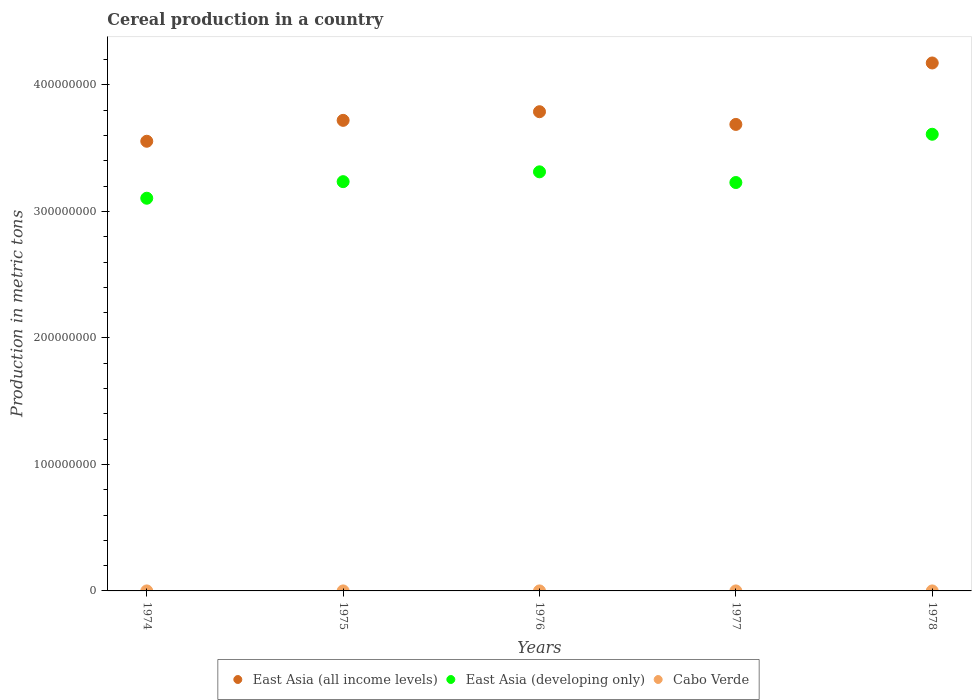Is the number of dotlines equal to the number of legend labels?
Provide a succinct answer. Yes. What is the total cereal production in East Asia (developing only) in 1977?
Your answer should be compact. 3.23e+08. Across all years, what is the maximum total cereal production in East Asia (developing only)?
Make the answer very short. 3.61e+08. Across all years, what is the minimum total cereal production in East Asia (developing only)?
Give a very brief answer. 3.10e+08. In which year was the total cereal production in East Asia (all income levels) maximum?
Your answer should be compact. 1978. In which year was the total cereal production in East Asia (developing only) minimum?
Give a very brief answer. 1974. What is the total total cereal production in East Asia (all income levels) in the graph?
Your response must be concise. 1.89e+09. What is the difference between the total cereal production in East Asia (all income levels) in 1974 and that in 1977?
Offer a very short reply. -1.33e+07. What is the difference between the total cereal production in East Asia (all income levels) in 1978 and the total cereal production in East Asia (developing only) in 1977?
Provide a short and direct response. 9.45e+07. What is the average total cereal production in East Asia (developing only) per year?
Provide a short and direct response. 3.30e+08. In the year 1977, what is the difference between the total cereal production in East Asia (all income levels) and total cereal production in Cabo Verde?
Offer a terse response. 3.69e+08. In how many years, is the total cereal production in East Asia (all income levels) greater than 240000000 metric tons?
Keep it short and to the point. 5. What is the ratio of the total cereal production in East Asia (all income levels) in 1974 to that in 1978?
Ensure brevity in your answer.  0.85. Is the difference between the total cereal production in East Asia (all income levels) in 1975 and 1978 greater than the difference between the total cereal production in Cabo Verde in 1975 and 1978?
Make the answer very short. No. What is the difference between the highest and the second highest total cereal production in Cabo Verde?
Provide a succinct answer. 1000. What is the difference between the highest and the lowest total cereal production in Cabo Verde?
Offer a terse response. 4000. Is the sum of the total cereal production in East Asia (developing only) in 1974 and 1976 greater than the maximum total cereal production in Cabo Verde across all years?
Ensure brevity in your answer.  Yes. Does the total cereal production in Cabo Verde monotonically increase over the years?
Give a very brief answer. No. How many dotlines are there?
Keep it short and to the point. 3. What is the difference between two consecutive major ticks on the Y-axis?
Offer a very short reply. 1.00e+08. Are the values on the major ticks of Y-axis written in scientific E-notation?
Your answer should be compact. No. Does the graph contain grids?
Ensure brevity in your answer.  No. How many legend labels are there?
Offer a terse response. 3. What is the title of the graph?
Offer a very short reply. Cereal production in a country. What is the label or title of the X-axis?
Offer a terse response. Years. What is the label or title of the Y-axis?
Ensure brevity in your answer.  Production in metric tons. What is the Production in metric tons of East Asia (all income levels) in 1974?
Make the answer very short. 3.55e+08. What is the Production in metric tons in East Asia (developing only) in 1974?
Your answer should be compact. 3.10e+08. What is the Production in metric tons of Cabo Verde in 1974?
Your answer should be compact. 2200. What is the Production in metric tons of East Asia (all income levels) in 1975?
Give a very brief answer. 3.72e+08. What is the Production in metric tons of East Asia (developing only) in 1975?
Your answer should be very brief. 3.24e+08. What is the Production in metric tons in Cabo Verde in 1975?
Offer a terse response. 4000. What is the Production in metric tons of East Asia (all income levels) in 1976?
Provide a short and direct response. 3.79e+08. What is the Production in metric tons of East Asia (developing only) in 1976?
Give a very brief answer. 3.31e+08. What is the Production in metric tons of East Asia (all income levels) in 1977?
Offer a terse response. 3.69e+08. What is the Production in metric tons in East Asia (developing only) in 1977?
Your response must be concise. 3.23e+08. What is the Production in metric tons in Cabo Verde in 1977?
Ensure brevity in your answer.  1500. What is the Production in metric tons in East Asia (all income levels) in 1978?
Give a very brief answer. 4.17e+08. What is the Production in metric tons of East Asia (developing only) in 1978?
Your answer should be compact. 3.61e+08. What is the Production in metric tons in Cabo Verde in 1978?
Provide a short and direct response. 1000. Across all years, what is the maximum Production in metric tons in East Asia (all income levels)?
Make the answer very short. 4.17e+08. Across all years, what is the maximum Production in metric tons of East Asia (developing only)?
Offer a terse response. 3.61e+08. Across all years, what is the minimum Production in metric tons in East Asia (all income levels)?
Offer a very short reply. 3.55e+08. Across all years, what is the minimum Production in metric tons in East Asia (developing only)?
Offer a terse response. 3.10e+08. What is the total Production in metric tons of East Asia (all income levels) in the graph?
Provide a succinct answer. 1.89e+09. What is the total Production in metric tons of East Asia (developing only) in the graph?
Keep it short and to the point. 1.65e+09. What is the total Production in metric tons of Cabo Verde in the graph?
Offer a very short reply. 1.37e+04. What is the difference between the Production in metric tons in East Asia (all income levels) in 1974 and that in 1975?
Provide a succinct answer. -1.65e+07. What is the difference between the Production in metric tons in East Asia (developing only) in 1974 and that in 1975?
Your response must be concise. -1.31e+07. What is the difference between the Production in metric tons in Cabo Verde in 1974 and that in 1975?
Provide a short and direct response. -1800. What is the difference between the Production in metric tons of East Asia (all income levels) in 1974 and that in 1976?
Provide a short and direct response. -2.34e+07. What is the difference between the Production in metric tons of East Asia (developing only) in 1974 and that in 1976?
Make the answer very short. -2.09e+07. What is the difference between the Production in metric tons of Cabo Verde in 1974 and that in 1976?
Provide a succinct answer. -2800. What is the difference between the Production in metric tons of East Asia (all income levels) in 1974 and that in 1977?
Your response must be concise. -1.33e+07. What is the difference between the Production in metric tons in East Asia (developing only) in 1974 and that in 1977?
Offer a very short reply. -1.24e+07. What is the difference between the Production in metric tons in Cabo Verde in 1974 and that in 1977?
Your response must be concise. 700. What is the difference between the Production in metric tons in East Asia (all income levels) in 1974 and that in 1978?
Your answer should be compact. -6.19e+07. What is the difference between the Production in metric tons of East Asia (developing only) in 1974 and that in 1978?
Provide a short and direct response. -5.06e+07. What is the difference between the Production in metric tons in Cabo Verde in 1974 and that in 1978?
Give a very brief answer. 1200. What is the difference between the Production in metric tons in East Asia (all income levels) in 1975 and that in 1976?
Provide a succinct answer. -6.84e+06. What is the difference between the Production in metric tons in East Asia (developing only) in 1975 and that in 1976?
Your response must be concise. -7.76e+06. What is the difference between the Production in metric tons of Cabo Verde in 1975 and that in 1976?
Your answer should be compact. -1000. What is the difference between the Production in metric tons of East Asia (all income levels) in 1975 and that in 1977?
Provide a succinct answer. 3.21e+06. What is the difference between the Production in metric tons of East Asia (developing only) in 1975 and that in 1977?
Offer a terse response. 6.87e+05. What is the difference between the Production in metric tons in Cabo Verde in 1975 and that in 1977?
Offer a very short reply. 2500. What is the difference between the Production in metric tons of East Asia (all income levels) in 1975 and that in 1978?
Provide a succinct answer. -4.54e+07. What is the difference between the Production in metric tons in East Asia (developing only) in 1975 and that in 1978?
Offer a terse response. -3.75e+07. What is the difference between the Production in metric tons of Cabo Verde in 1975 and that in 1978?
Keep it short and to the point. 3000. What is the difference between the Production in metric tons in East Asia (all income levels) in 1976 and that in 1977?
Keep it short and to the point. 1.00e+07. What is the difference between the Production in metric tons in East Asia (developing only) in 1976 and that in 1977?
Your answer should be very brief. 8.45e+06. What is the difference between the Production in metric tons in Cabo Verde in 1976 and that in 1977?
Your answer should be compact. 3500. What is the difference between the Production in metric tons in East Asia (all income levels) in 1976 and that in 1978?
Offer a very short reply. -3.85e+07. What is the difference between the Production in metric tons of East Asia (developing only) in 1976 and that in 1978?
Your answer should be very brief. -2.97e+07. What is the difference between the Production in metric tons in Cabo Verde in 1976 and that in 1978?
Your answer should be very brief. 4000. What is the difference between the Production in metric tons of East Asia (all income levels) in 1977 and that in 1978?
Provide a short and direct response. -4.86e+07. What is the difference between the Production in metric tons of East Asia (developing only) in 1977 and that in 1978?
Give a very brief answer. -3.82e+07. What is the difference between the Production in metric tons in Cabo Verde in 1977 and that in 1978?
Offer a very short reply. 500. What is the difference between the Production in metric tons of East Asia (all income levels) in 1974 and the Production in metric tons of East Asia (developing only) in 1975?
Your answer should be very brief. 3.19e+07. What is the difference between the Production in metric tons in East Asia (all income levels) in 1974 and the Production in metric tons in Cabo Verde in 1975?
Offer a terse response. 3.55e+08. What is the difference between the Production in metric tons in East Asia (developing only) in 1974 and the Production in metric tons in Cabo Verde in 1975?
Provide a short and direct response. 3.10e+08. What is the difference between the Production in metric tons in East Asia (all income levels) in 1974 and the Production in metric tons in East Asia (developing only) in 1976?
Make the answer very short. 2.42e+07. What is the difference between the Production in metric tons in East Asia (all income levels) in 1974 and the Production in metric tons in Cabo Verde in 1976?
Offer a very short reply. 3.55e+08. What is the difference between the Production in metric tons of East Asia (developing only) in 1974 and the Production in metric tons of Cabo Verde in 1976?
Provide a short and direct response. 3.10e+08. What is the difference between the Production in metric tons in East Asia (all income levels) in 1974 and the Production in metric tons in East Asia (developing only) in 1977?
Make the answer very short. 3.26e+07. What is the difference between the Production in metric tons in East Asia (all income levels) in 1974 and the Production in metric tons in Cabo Verde in 1977?
Give a very brief answer. 3.55e+08. What is the difference between the Production in metric tons of East Asia (developing only) in 1974 and the Production in metric tons of Cabo Verde in 1977?
Give a very brief answer. 3.10e+08. What is the difference between the Production in metric tons in East Asia (all income levels) in 1974 and the Production in metric tons in East Asia (developing only) in 1978?
Your answer should be compact. -5.53e+06. What is the difference between the Production in metric tons in East Asia (all income levels) in 1974 and the Production in metric tons in Cabo Verde in 1978?
Your response must be concise. 3.55e+08. What is the difference between the Production in metric tons of East Asia (developing only) in 1974 and the Production in metric tons of Cabo Verde in 1978?
Your response must be concise. 3.10e+08. What is the difference between the Production in metric tons in East Asia (all income levels) in 1975 and the Production in metric tons in East Asia (developing only) in 1976?
Your response must be concise. 4.07e+07. What is the difference between the Production in metric tons in East Asia (all income levels) in 1975 and the Production in metric tons in Cabo Verde in 1976?
Your answer should be very brief. 3.72e+08. What is the difference between the Production in metric tons of East Asia (developing only) in 1975 and the Production in metric tons of Cabo Verde in 1976?
Ensure brevity in your answer.  3.24e+08. What is the difference between the Production in metric tons of East Asia (all income levels) in 1975 and the Production in metric tons of East Asia (developing only) in 1977?
Your answer should be compact. 4.91e+07. What is the difference between the Production in metric tons in East Asia (all income levels) in 1975 and the Production in metric tons in Cabo Verde in 1977?
Provide a succinct answer. 3.72e+08. What is the difference between the Production in metric tons of East Asia (developing only) in 1975 and the Production in metric tons of Cabo Verde in 1977?
Give a very brief answer. 3.24e+08. What is the difference between the Production in metric tons in East Asia (all income levels) in 1975 and the Production in metric tons in East Asia (developing only) in 1978?
Keep it short and to the point. 1.10e+07. What is the difference between the Production in metric tons of East Asia (all income levels) in 1975 and the Production in metric tons of Cabo Verde in 1978?
Provide a succinct answer. 3.72e+08. What is the difference between the Production in metric tons of East Asia (developing only) in 1975 and the Production in metric tons of Cabo Verde in 1978?
Keep it short and to the point. 3.24e+08. What is the difference between the Production in metric tons of East Asia (all income levels) in 1976 and the Production in metric tons of East Asia (developing only) in 1977?
Provide a succinct answer. 5.60e+07. What is the difference between the Production in metric tons of East Asia (all income levels) in 1976 and the Production in metric tons of Cabo Verde in 1977?
Give a very brief answer. 3.79e+08. What is the difference between the Production in metric tons of East Asia (developing only) in 1976 and the Production in metric tons of Cabo Verde in 1977?
Provide a short and direct response. 3.31e+08. What is the difference between the Production in metric tons in East Asia (all income levels) in 1976 and the Production in metric tons in East Asia (developing only) in 1978?
Give a very brief answer. 1.78e+07. What is the difference between the Production in metric tons in East Asia (all income levels) in 1976 and the Production in metric tons in Cabo Verde in 1978?
Give a very brief answer. 3.79e+08. What is the difference between the Production in metric tons in East Asia (developing only) in 1976 and the Production in metric tons in Cabo Verde in 1978?
Your response must be concise. 3.31e+08. What is the difference between the Production in metric tons in East Asia (all income levels) in 1977 and the Production in metric tons in East Asia (developing only) in 1978?
Provide a succinct answer. 7.77e+06. What is the difference between the Production in metric tons in East Asia (all income levels) in 1977 and the Production in metric tons in Cabo Verde in 1978?
Your answer should be very brief. 3.69e+08. What is the difference between the Production in metric tons of East Asia (developing only) in 1977 and the Production in metric tons of Cabo Verde in 1978?
Make the answer very short. 3.23e+08. What is the average Production in metric tons in East Asia (all income levels) per year?
Provide a succinct answer. 3.78e+08. What is the average Production in metric tons in East Asia (developing only) per year?
Ensure brevity in your answer.  3.30e+08. What is the average Production in metric tons in Cabo Verde per year?
Your answer should be very brief. 2740. In the year 1974, what is the difference between the Production in metric tons in East Asia (all income levels) and Production in metric tons in East Asia (developing only)?
Make the answer very short. 4.50e+07. In the year 1974, what is the difference between the Production in metric tons of East Asia (all income levels) and Production in metric tons of Cabo Verde?
Give a very brief answer. 3.55e+08. In the year 1974, what is the difference between the Production in metric tons of East Asia (developing only) and Production in metric tons of Cabo Verde?
Make the answer very short. 3.10e+08. In the year 1975, what is the difference between the Production in metric tons in East Asia (all income levels) and Production in metric tons in East Asia (developing only)?
Provide a succinct answer. 4.85e+07. In the year 1975, what is the difference between the Production in metric tons of East Asia (all income levels) and Production in metric tons of Cabo Verde?
Your answer should be very brief. 3.72e+08. In the year 1975, what is the difference between the Production in metric tons of East Asia (developing only) and Production in metric tons of Cabo Verde?
Your answer should be very brief. 3.24e+08. In the year 1976, what is the difference between the Production in metric tons in East Asia (all income levels) and Production in metric tons in East Asia (developing only)?
Ensure brevity in your answer.  4.75e+07. In the year 1976, what is the difference between the Production in metric tons of East Asia (all income levels) and Production in metric tons of Cabo Verde?
Offer a terse response. 3.79e+08. In the year 1976, what is the difference between the Production in metric tons in East Asia (developing only) and Production in metric tons in Cabo Verde?
Provide a succinct answer. 3.31e+08. In the year 1977, what is the difference between the Production in metric tons of East Asia (all income levels) and Production in metric tons of East Asia (developing only)?
Provide a succinct answer. 4.59e+07. In the year 1977, what is the difference between the Production in metric tons in East Asia (all income levels) and Production in metric tons in Cabo Verde?
Your response must be concise. 3.69e+08. In the year 1977, what is the difference between the Production in metric tons of East Asia (developing only) and Production in metric tons of Cabo Verde?
Make the answer very short. 3.23e+08. In the year 1978, what is the difference between the Production in metric tons in East Asia (all income levels) and Production in metric tons in East Asia (developing only)?
Ensure brevity in your answer.  5.64e+07. In the year 1978, what is the difference between the Production in metric tons of East Asia (all income levels) and Production in metric tons of Cabo Verde?
Offer a terse response. 4.17e+08. In the year 1978, what is the difference between the Production in metric tons in East Asia (developing only) and Production in metric tons in Cabo Verde?
Ensure brevity in your answer.  3.61e+08. What is the ratio of the Production in metric tons in East Asia (all income levels) in 1974 to that in 1975?
Give a very brief answer. 0.96. What is the ratio of the Production in metric tons of East Asia (developing only) in 1974 to that in 1975?
Your response must be concise. 0.96. What is the ratio of the Production in metric tons in Cabo Verde in 1974 to that in 1975?
Your response must be concise. 0.55. What is the ratio of the Production in metric tons of East Asia (all income levels) in 1974 to that in 1976?
Keep it short and to the point. 0.94. What is the ratio of the Production in metric tons in East Asia (developing only) in 1974 to that in 1976?
Your answer should be very brief. 0.94. What is the ratio of the Production in metric tons in Cabo Verde in 1974 to that in 1976?
Your answer should be compact. 0.44. What is the ratio of the Production in metric tons in East Asia (all income levels) in 1974 to that in 1977?
Give a very brief answer. 0.96. What is the ratio of the Production in metric tons in East Asia (developing only) in 1974 to that in 1977?
Provide a succinct answer. 0.96. What is the ratio of the Production in metric tons of Cabo Verde in 1974 to that in 1977?
Offer a very short reply. 1.47. What is the ratio of the Production in metric tons of East Asia (all income levels) in 1974 to that in 1978?
Provide a short and direct response. 0.85. What is the ratio of the Production in metric tons in East Asia (developing only) in 1974 to that in 1978?
Your answer should be very brief. 0.86. What is the ratio of the Production in metric tons in Cabo Verde in 1974 to that in 1978?
Provide a short and direct response. 2.2. What is the ratio of the Production in metric tons of East Asia (all income levels) in 1975 to that in 1976?
Provide a short and direct response. 0.98. What is the ratio of the Production in metric tons of East Asia (developing only) in 1975 to that in 1976?
Offer a very short reply. 0.98. What is the ratio of the Production in metric tons in Cabo Verde in 1975 to that in 1976?
Ensure brevity in your answer.  0.8. What is the ratio of the Production in metric tons in East Asia (all income levels) in 1975 to that in 1977?
Your response must be concise. 1.01. What is the ratio of the Production in metric tons of East Asia (developing only) in 1975 to that in 1977?
Give a very brief answer. 1. What is the ratio of the Production in metric tons of Cabo Verde in 1975 to that in 1977?
Provide a succinct answer. 2.67. What is the ratio of the Production in metric tons in East Asia (all income levels) in 1975 to that in 1978?
Provide a succinct answer. 0.89. What is the ratio of the Production in metric tons in East Asia (developing only) in 1975 to that in 1978?
Your response must be concise. 0.9. What is the ratio of the Production in metric tons of Cabo Verde in 1975 to that in 1978?
Your answer should be very brief. 4. What is the ratio of the Production in metric tons in East Asia (all income levels) in 1976 to that in 1977?
Offer a terse response. 1.03. What is the ratio of the Production in metric tons in East Asia (developing only) in 1976 to that in 1977?
Offer a terse response. 1.03. What is the ratio of the Production in metric tons in Cabo Verde in 1976 to that in 1977?
Your response must be concise. 3.33. What is the ratio of the Production in metric tons of East Asia (all income levels) in 1976 to that in 1978?
Provide a short and direct response. 0.91. What is the ratio of the Production in metric tons of East Asia (developing only) in 1976 to that in 1978?
Offer a terse response. 0.92. What is the ratio of the Production in metric tons in East Asia (all income levels) in 1977 to that in 1978?
Offer a terse response. 0.88. What is the ratio of the Production in metric tons of East Asia (developing only) in 1977 to that in 1978?
Offer a very short reply. 0.89. What is the difference between the highest and the second highest Production in metric tons in East Asia (all income levels)?
Provide a short and direct response. 3.85e+07. What is the difference between the highest and the second highest Production in metric tons of East Asia (developing only)?
Your response must be concise. 2.97e+07. What is the difference between the highest and the second highest Production in metric tons in Cabo Verde?
Offer a terse response. 1000. What is the difference between the highest and the lowest Production in metric tons of East Asia (all income levels)?
Offer a very short reply. 6.19e+07. What is the difference between the highest and the lowest Production in metric tons of East Asia (developing only)?
Your answer should be very brief. 5.06e+07. What is the difference between the highest and the lowest Production in metric tons in Cabo Verde?
Offer a very short reply. 4000. 